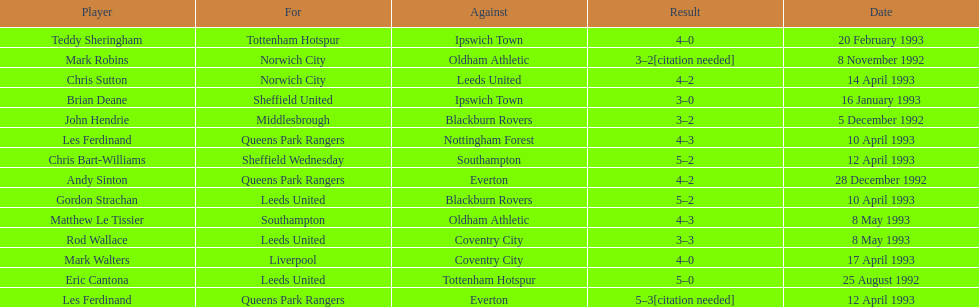Name the players for tottenham hotspur. Teddy Sheringham. 